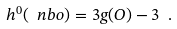<formula> <loc_0><loc_0><loc_500><loc_500>h ^ { 0 } ( \ n b o ) = 3 g ( O ) - 3 \ .</formula> 